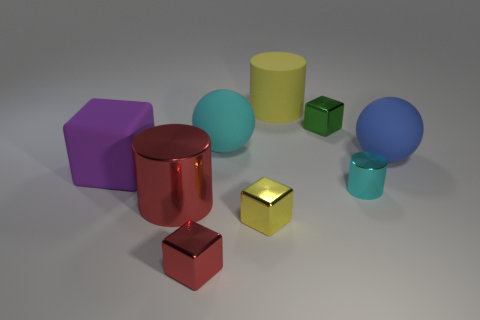Subtract 1 blocks. How many blocks are left? 3 Subtract all blue spheres. Subtract all brown blocks. How many spheres are left? 1 Subtract all spheres. How many objects are left? 7 Subtract all purple shiny balls. Subtract all red shiny objects. How many objects are left? 7 Add 3 red metal cylinders. How many red metal cylinders are left? 4 Add 8 cyan cylinders. How many cyan cylinders exist? 9 Subtract 1 cyan cylinders. How many objects are left? 8 